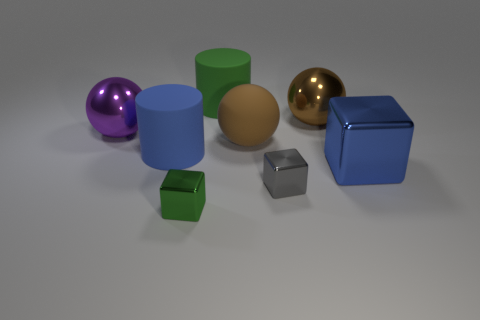Subtract all big brown metallic spheres. How many spheres are left? 2 Subtract all green cubes. How many brown spheres are left? 2 Add 1 blue cylinders. How many objects exist? 9 Subtract 1 spheres. How many spheres are left? 2 Subtract all green balls. Subtract all brown cylinders. How many balls are left? 3 Subtract 0 yellow cylinders. How many objects are left? 8 Subtract all balls. How many objects are left? 5 Subtract all big brown spheres. Subtract all big brown matte spheres. How many objects are left? 5 Add 1 tiny gray shiny blocks. How many tiny gray shiny blocks are left? 2 Add 4 tiny green metal objects. How many tiny green metal objects exist? 5 